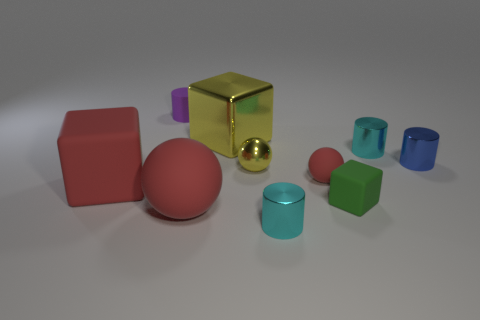How many other objects are the same color as the matte cylinder?
Your answer should be compact. 0. What number of blue objects are shiny objects or matte spheres?
Your response must be concise. 1. The blue object has what size?
Offer a terse response. Small. How many matte objects are small red balls or big red blocks?
Offer a very short reply. 2. Are there fewer small blue objects than small cyan cylinders?
Provide a short and direct response. Yes. What number of other objects are the same material as the big red sphere?
Offer a terse response. 4. What size is the matte thing that is the same shape as the tiny blue shiny object?
Provide a short and direct response. Small. Is the material of the tiny red object to the left of the green rubber thing the same as the small cyan object in front of the big red rubber block?
Provide a succinct answer. No. Are there fewer matte objects behind the small yellow thing than gray cylinders?
Offer a very short reply. No. Is there any other thing that has the same shape as the green matte thing?
Provide a succinct answer. Yes. 